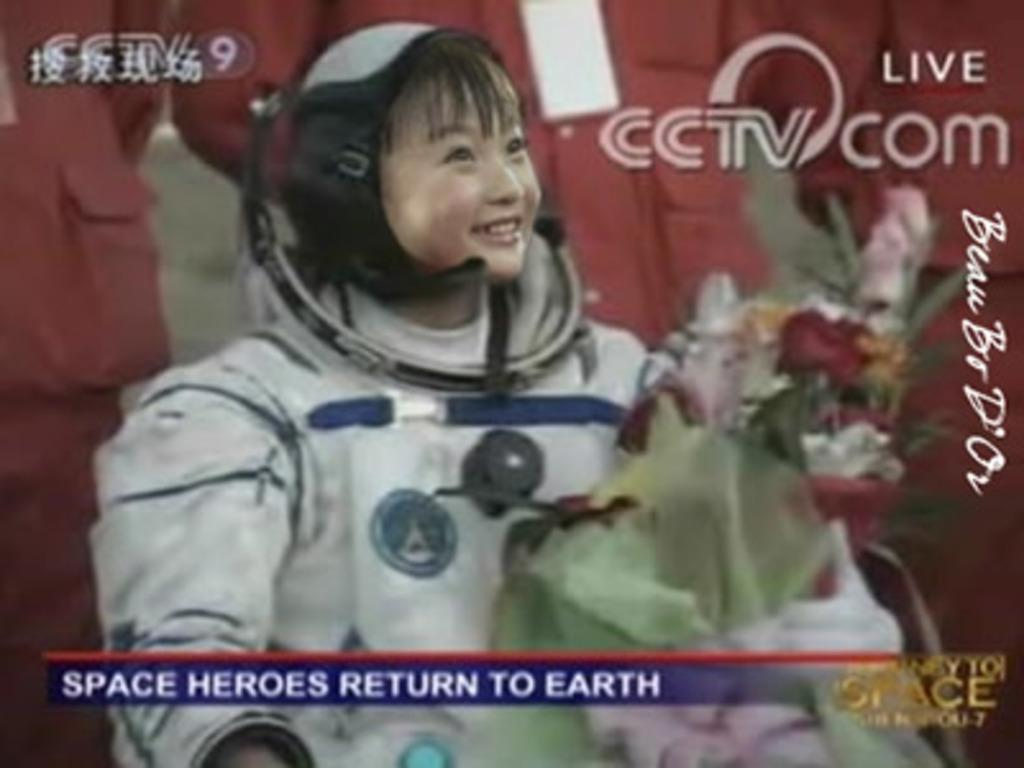Who or what is present in the image? There is a person in the image. What is the person wearing? The person is wearing a space jacket. What else can be seen in the image besides the person? There is a flower bouquet in the image. What type of creature is playing the drum in the image? There is no creature or drum present in the image. 